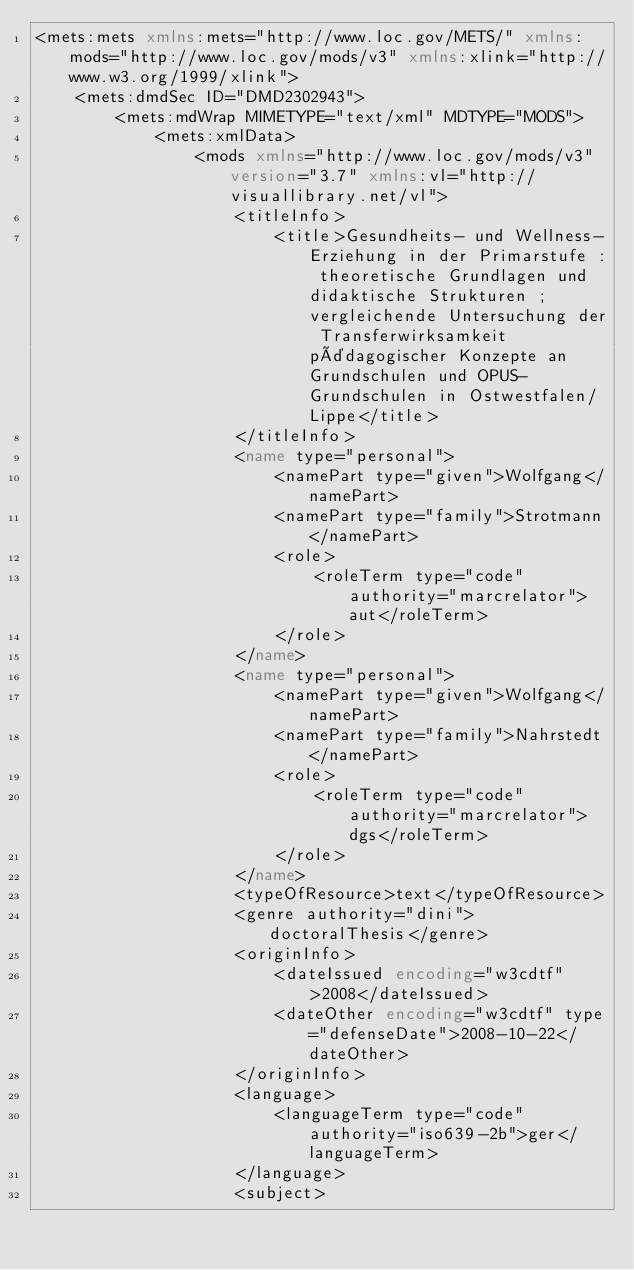<code> <loc_0><loc_0><loc_500><loc_500><_XML_><mets:mets xmlns:mets="http://www.loc.gov/METS/" xmlns:mods="http://www.loc.gov/mods/v3" xmlns:xlink="http://www.w3.org/1999/xlink">
    <mets:dmdSec ID="DMD2302943">
        <mets:mdWrap MIMETYPE="text/xml" MDTYPE="MODS">
            <mets:xmlData>
                <mods xmlns="http://www.loc.gov/mods/v3" version="3.7" xmlns:vl="http://visuallibrary.net/vl">
                    <titleInfo>
                        <title>Gesundheits- und Wellness-Erziehung in der Primarstufe : theoretische Grundlagen und didaktische Strukturen ; vergleichende Untersuchung der Transferwirksamkeit pädagogischer Konzepte an Grundschulen und OPUS-Grundschulen in Ostwestfalen/Lippe</title>
                    </titleInfo>
                    <name type="personal">
                        <namePart type="given">Wolfgang</namePart>
                        <namePart type="family">Strotmann</namePart>
                        <role>
                            <roleTerm type="code" authority="marcrelator">aut</roleTerm>
                        </role>
                    </name>
                    <name type="personal">
                        <namePart type="given">Wolfgang</namePart>
                        <namePart type="family">Nahrstedt</namePart>
                        <role>
                            <roleTerm type="code" authority="marcrelator">dgs</roleTerm>
                        </role>
                    </name>
                    <typeOfResource>text</typeOfResource>
                    <genre authority="dini">doctoralThesis</genre>
                    <originInfo>
                        <dateIssued encoding="w3cdtf">2008</dateIssued>
                        <dateOther encoding="w3cdtf" type="defenseDate">2008-10-22</dateOther>
                    </originInfo>
                    <language>
                        <languageTerm type="code" authority="iso639-2b">ger</languageTerm>
                    </language>
                    <subject></code> 